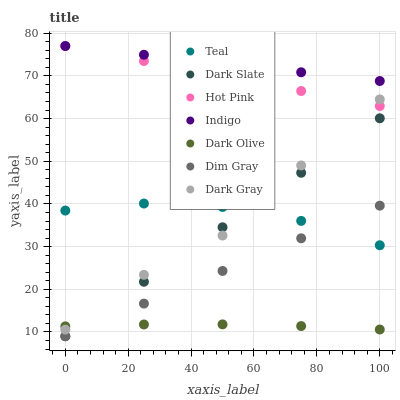Does Dark Olive have the minimum area under the curve?
Answer yes or no. Yes. Does Indigo have the maximum area under the curve?
Answer yes or no. Yes. Does Indigo have the minimum area under the curve?
Answer yes or no. No. Does Dark Olive have the maximum area under the curve?
Answer yes or no. No. Is Indigo the smoothest?
Answer yes or no. Yes. Is Dark Gray the roughest?
Answer yes or no. Yes. Is Dark Olive the smoothest?
Answer yes or no. No. Is Dark Olive the roughest?
Answer yes or no. No. Does Dim Gray have the lowest value?
Answer yes or no. Yes. Does Dark Olive have the lowest value?
Answer yes or no. No. Does Hot Pink have the highest value?
Answer yes or no. Yes. Does Dark Olive have the highest value?
Answer yes or no. No. Is Dim Gray less than Indigo?
Answer yes or no. Yes. Is Dark Gray greater than Dim Gray?
Answer yes or no. Yes. Does Dim Gray intersect Teal?
Answer yes or no. Yes. Is Dim Gray less than Teal?
Answer yes or no. No. Is Dim Gray greater than Teal?
Answer yes or no. No. Does Dim Gray intersect Indigo?
Answer yes or no. No. 